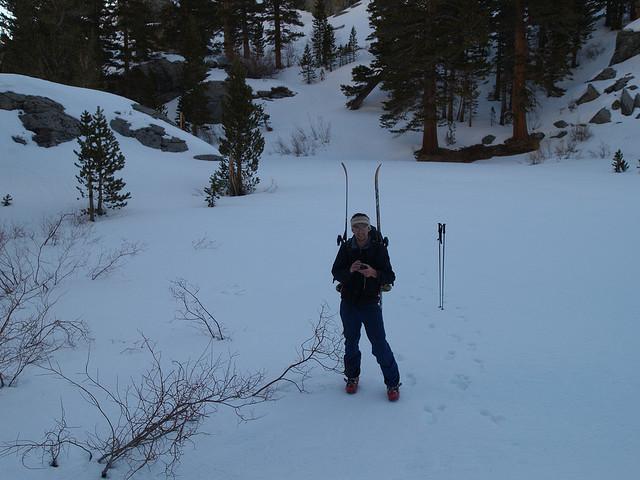Is this person a male or female?
Be succinct. Male. Why are there sticks in the snow?
Answer briefly. Skis. What are the people doing?
Answer briefly. Skiing. Is this person skiing?
Short answer required. No. Does this person have skis on?
Keep it brief. No. How many people are walking?
Keep it brief. 1. Are there people standing around?
Quick response, please. Yes. Is the man in the picture wearing skis?
Give a very brief answer. No. What is the person doing with their knees?
Quick response, please. Bending. Is this a mountain?
Short answer required. Yes. What does the person have on feet?
Write a very short answer. Boots. 